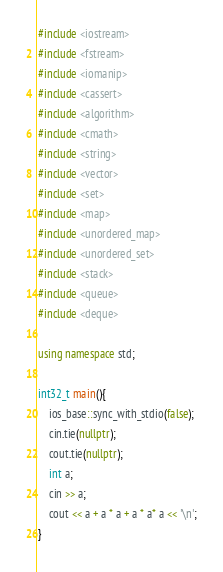Convert code to text. <code><loc_0><loc_0><loc_500><loc_500><_C++_>#include <iostream>
#include <fstream>
#include <iomanip>
#include <cassert>
#include <algorithm>
#include <cmath>
#include <string>
#include <vector>
#include <set>
#include <map>
#include <unordered_map>
#include <unordered_set>
#include <stack>
#include <queue>
#include <deque>

using namespace std;

int32_t main(){
    ios_base::sync_with_stdio(false);
    cin.tie(nullptr);
    cout.tie(nullptr);
    int a;
    cin >> a;
    cout << a + a * a + a * a* a << '\n';
}</code> 